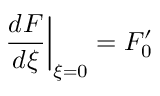<formula> <loc_0><loc_0><loc_500><loc_500>\frac { d F } { d \xi } \right | _ { \xi = 0 } = F _ { 0 } ^ { \prime }</formula> 